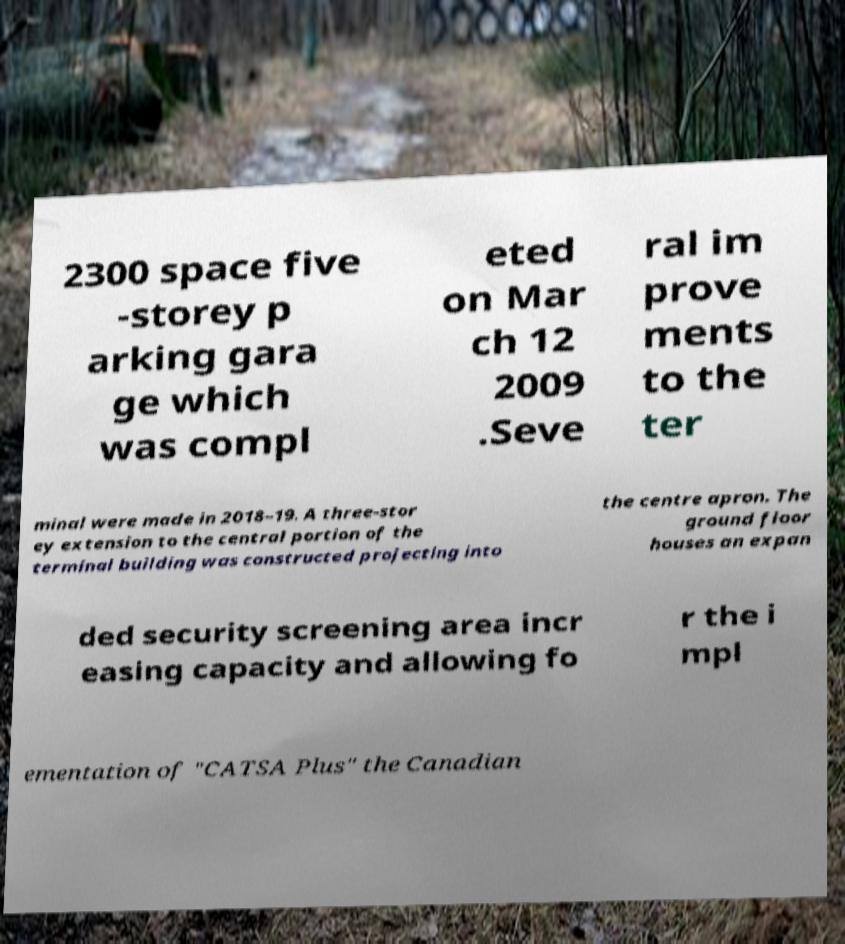Could you assist in decoding the text presented in this image and type it out clearly? 2300 space five -storey p arking gara ge which was compl eted on Mar ch 12 2009 .Seve ral im prove ments to the ter minal were made in 2018–19. A three-stor ey extension to the central portion of the terminal building was constructed projecting into the centre apron. The ground floor houses an expan ded security screening area incr easing capacity and allowing fo r the i mpl ementation of "CATSA Plus" the Canadian 